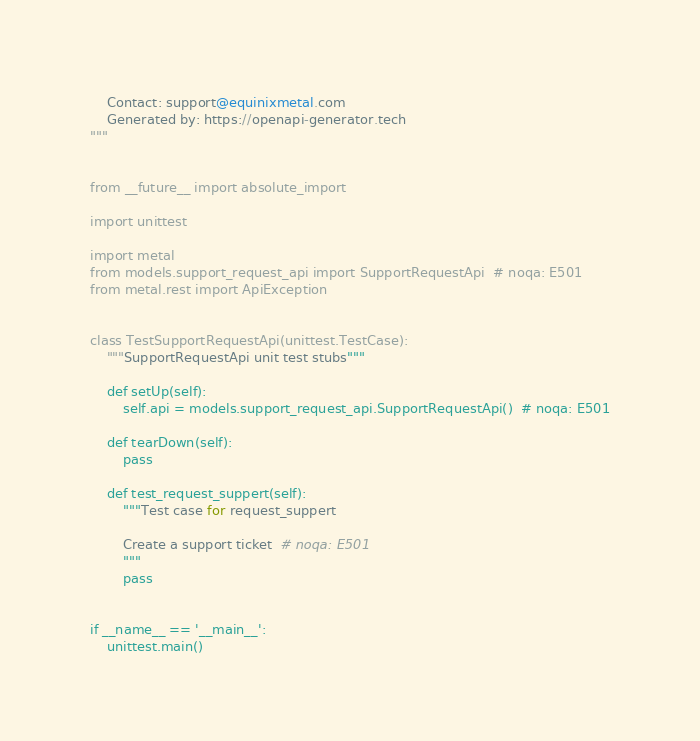<code> <loc_0><loc_0><loc_500><loc_500><_Python_>    Contact: support@equinixmetal.com
    Generated by: https://openapi-generator.tech
"""


from __future__ import absolute_import

import unittest

import metal
from models.support_request_api import SupportRequestApi  # noqa: E501
from metal.rest import ApiException


class TestSupportRequestApi(unittest.TestCase):
    """SupportRequestApi unit test stubs"""

    def setUp(self):
        self.api = models.support_request_api.SupportRequestApi()  # noqa: E501

    def tearDown(self):
        pass

    def test_request_suppert(self):
        """Test case for request_suppert

        Create a support ticket  # noqa: E501
        """
        pass


if __name__ == '__main__':
    unittest.main()
</code> 